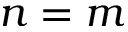<formula> <loc_0><loc_0><loc_500><loc_500>n = m</formula> 